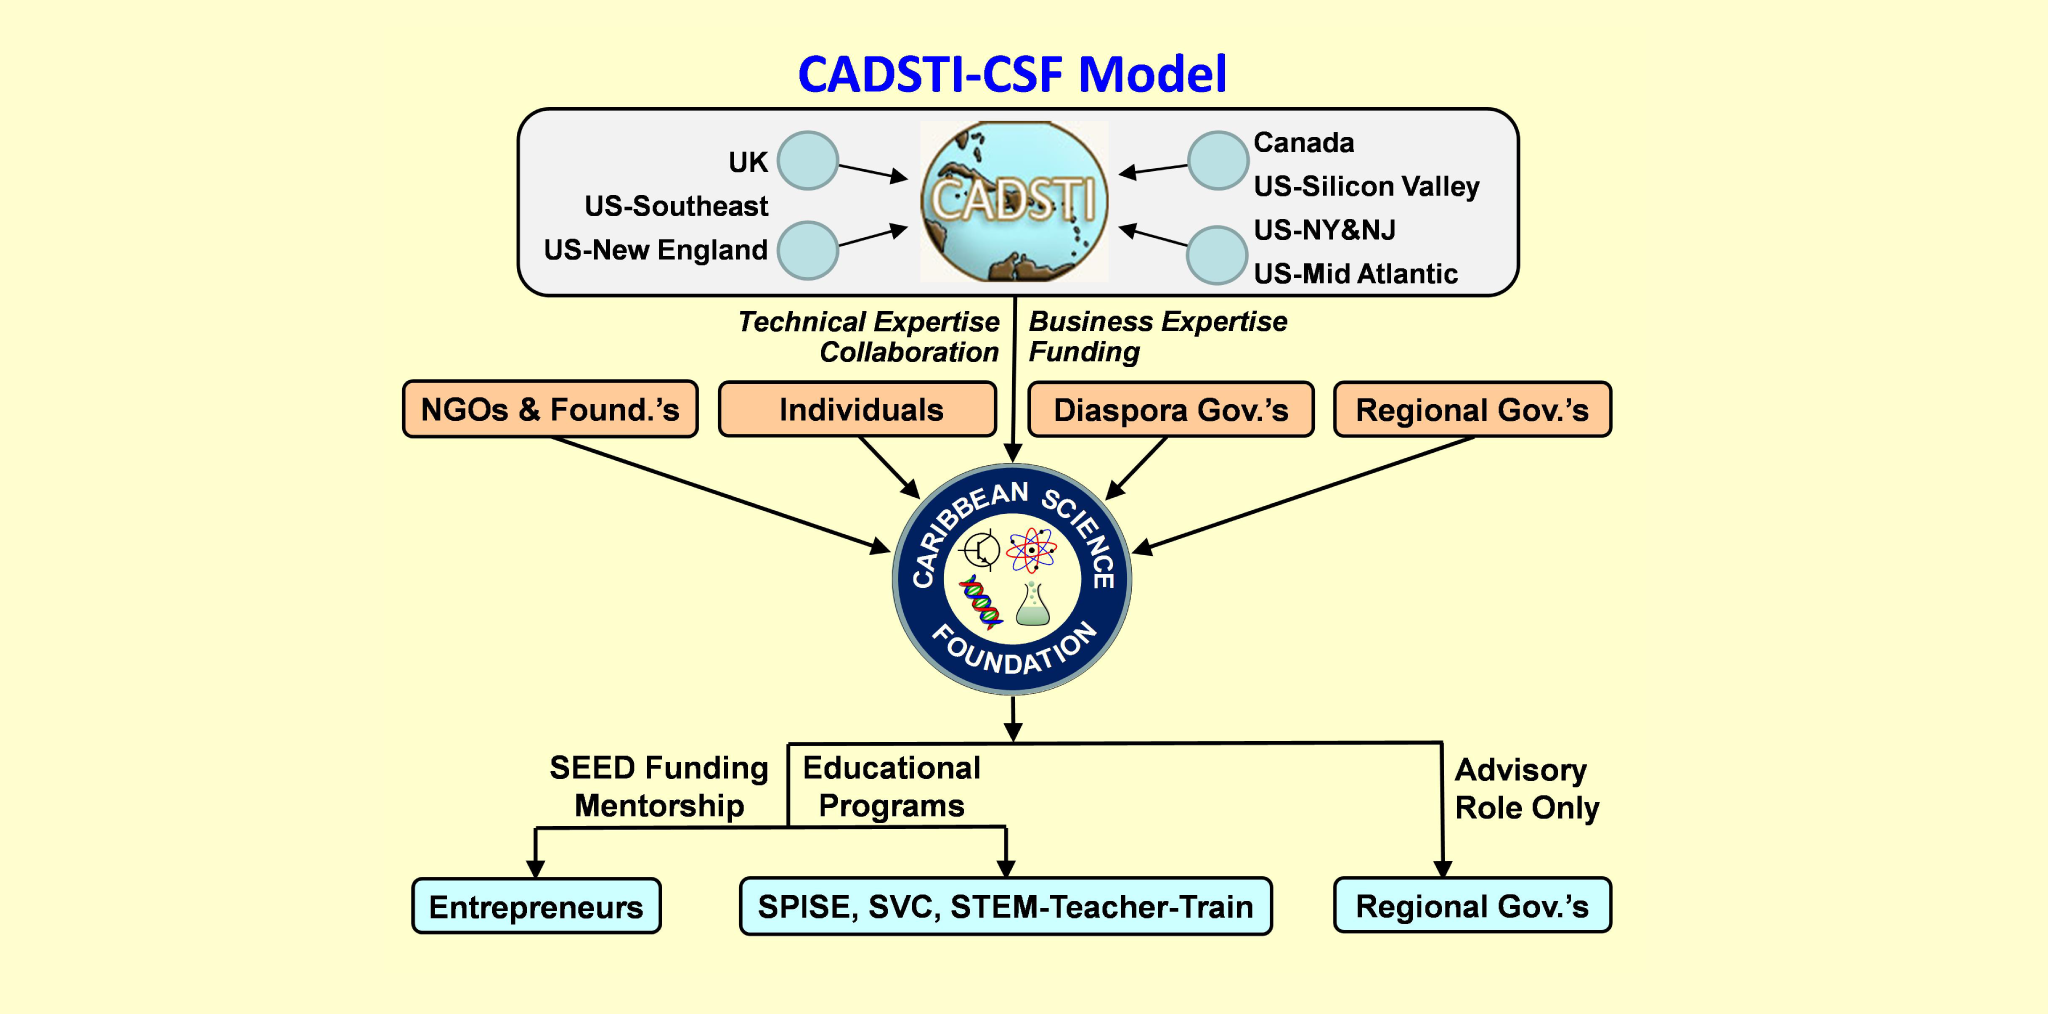Should the Caribbean Science Foundation launch a global online platform to connect Caribbean students with international researchers? What could be the potential benefits? Launching a global online platform to connect Caribbean students with international researchers would have numerous potential benefits. It would provide students with access to a wealth of knowledge and expertise beyond their local communities, fostering collaboration on cutting-edge research projects. The platform could facilitate virtual internships, joint publications, and participation in global scientific conferences. Additionally, it would help build a global network of Caribbean scientists and researchers, enhancing career prospects for students and driving innovation. Such a platform would amplify the Caribbean Science Foundation's mission of promoting science education and fostering a vibrant scientific community in the region. How could this platform be designed to ensure maximum engagement from both students and researchers? To ensure maximum engagement from both students and researchers, the platform should incorporate interactive features such as discussion forums, live Q&A sessions, and collaborative project workspaces. Gamification elements like badges and leaderboards could motivate participation. Additionally, the platform should offer flexible, user-friendly interfaces optimized for both desktop and mobile devices. Regularly scheduled webinars and workshops hosted by prominent researchers could keep content fresh and engaging. Finally, integrating AI-driven recommendations for potential collaborators and personalized content could enhance the user experience, making the platform a valuable and indispensable resource for both students and researchers. 